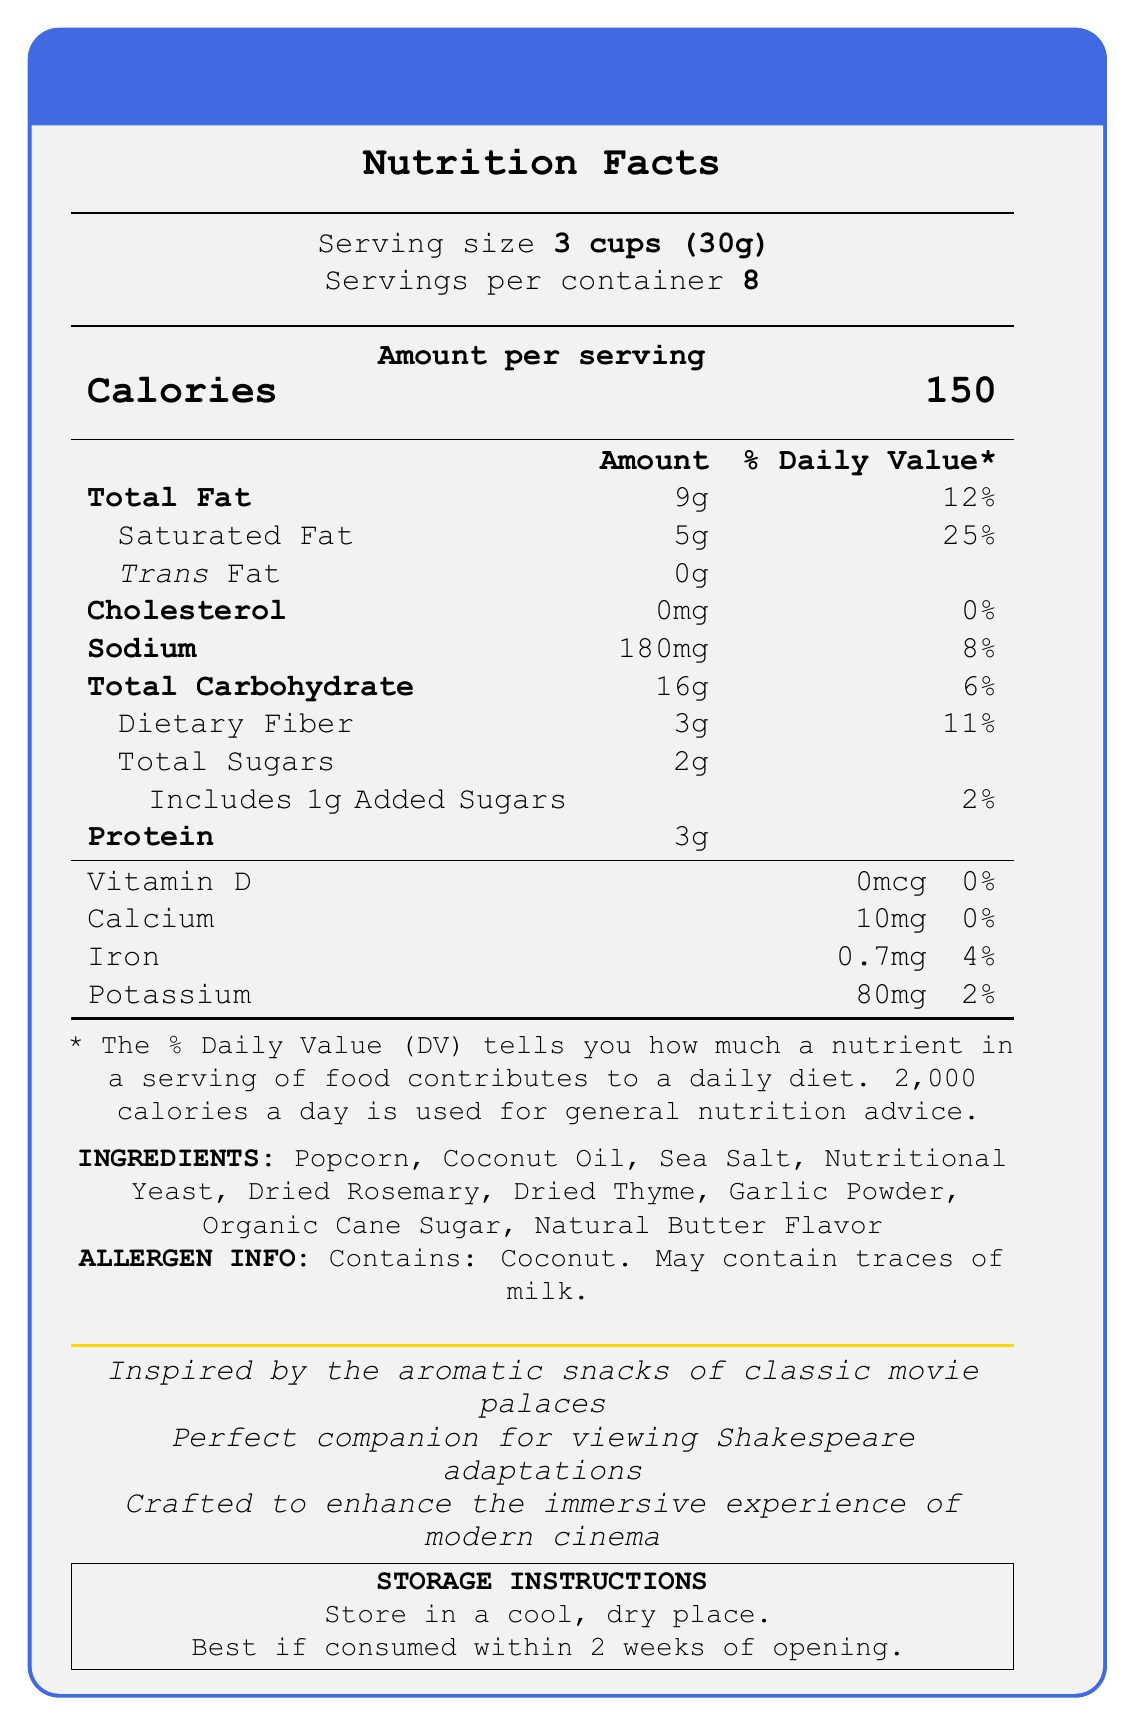what is the product name? The product name is stated at the top of the document.
Answer: Act III Gourmet Theater Popcorn Blend How many servings are there per container? The document specifies that there are 8 servings per container.
Answer: 8 What is the serving size? The serving size is listed as 3 cups (30g) in the document.
Answer: 3 cups (30g) What is the amount of calories per serving? The document states that one serving contains 150 calories.
Answer: 150 How much saturated fat does one serving contain? The amount of saturated fat per serving is listed as 5g.
Answer: 5g How much dietary fiber is in each serving? The document indicates that each serving contains 3g of dietary fiber.
Answer: 3g how much cholesterol does the popcorn contain per serving? The document states that the cholesterol content per serving is 0mg, with 0% daily value.
Answer: 0mg What is the percentage of daily value for sodium per serving? The sodium content per serving amounts to 180mg, which is 8% of the daily value.
Answer: 8% What are the main ingredients in the popcorn blend? The document lists these ingredients in the "Ingredients" section.
Answer: Popcorn, Coconut Oil, Sea Salt, Nutritional Yeast, Dried Rosemary, Dried Thyme, Garlic Powder, Organic Cane Sugar, Natural Butter Flavor Which allergens are present in the popcorn blend? A. Milk B. Peanuts C. Coconut D. Soy The allergen information specifies that the product contains Coconut and may contain traces of milk.
Answer: C. Coconut Which nutrient contributes 0% to the daily value? A. Sodium B. Iron C. Potassium D. Vitamin D The document lists Vitamin D as contributing 0% to the daily value.
Answer: D. Vitamin D Is the document inspired by aromatic snacks of classic movie palaces? The document explicitly states that it is inspired by the aromatic snacks of classic movie palaces.
Answer: Yes Does the popcorn blend include added sugars? The document mentions that it includes 1g of added sugars, contributing 2% to the daily value.
Answer: Yes Summarize the main features of the document. The summary covers the nutritional facts, ingredients, allergen info, inspiration, and storage instructions detailed in the document.
Answer: The document provides nutritional information for the "Act III Gourmet Theater Popcorn Blend," including serving size, calorie content, and daily values for various nutrients. It lists ingredients and allergen information and highlights the product's cinematic inspiration and ideal pairing with Shakespeare adaptations. Storage instructions are also provided. how much protein is in the blend per serving? The document states that each serving contains 3g of protein.
Answer: 3g What should be the storage condition for the popcorn blend? The document advises on storage conditions in the "Storage Instructions" section.
Answer: Store in a cool, dry place. Best if consumed within 2 weeks of opening. Which vitamin/mineral has the lowest daily value percentage? The document shows that Vitamin D has a daily value percentage of 0%, which is the lowest among the listed vitamins and minerals.
Answer: Vitamin D Is the product suitable for vegans? The document does not explicitly state whether the product is suitable for vegans. The presence of "Natural Butter Flavor" and potential traces of milk could be a concern for vegans.
Answer: Not enough information 